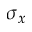<formula> <loc_0><loc_0><loc_500><loc_500>\sigma _ { x }</formula> 